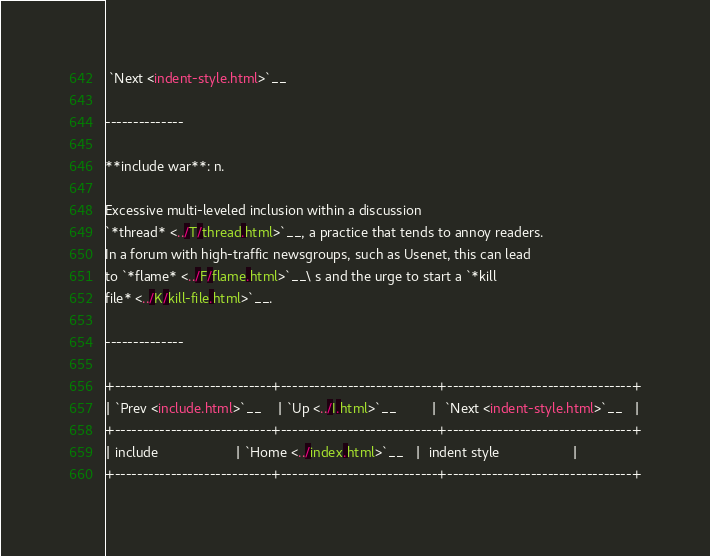<code> <loc_0><loc_0><loc_500><loc_500><_HTML_> `Next <indent-style.html>`__

--------------

**include war**: n.

Excessive multi-leveled inclusion within a discussion
`*thread* <../T/thread.html>`__, a practice that tends to annoy readers.
In a forum with high-traffic newsgroups, such as Usenet, this can lead
to `*flame* <../F/flame.html>`__\ s and the urge to start a `*kill
file* <../K/kill-file.html>`__.

--------------

+----------------------------+----------------------------+---------------------------------+
| `Prev <include.html>`__    | `Up <../I.html>`__         |  `Next <indent-style.html>`__   |
+----------------------------+----------------------------+---------------------------------+
| include                    | `Home <../index.html>`__   |  indent style                   |
+----------------------------+----------------------------+---------------------------------+

</code> 